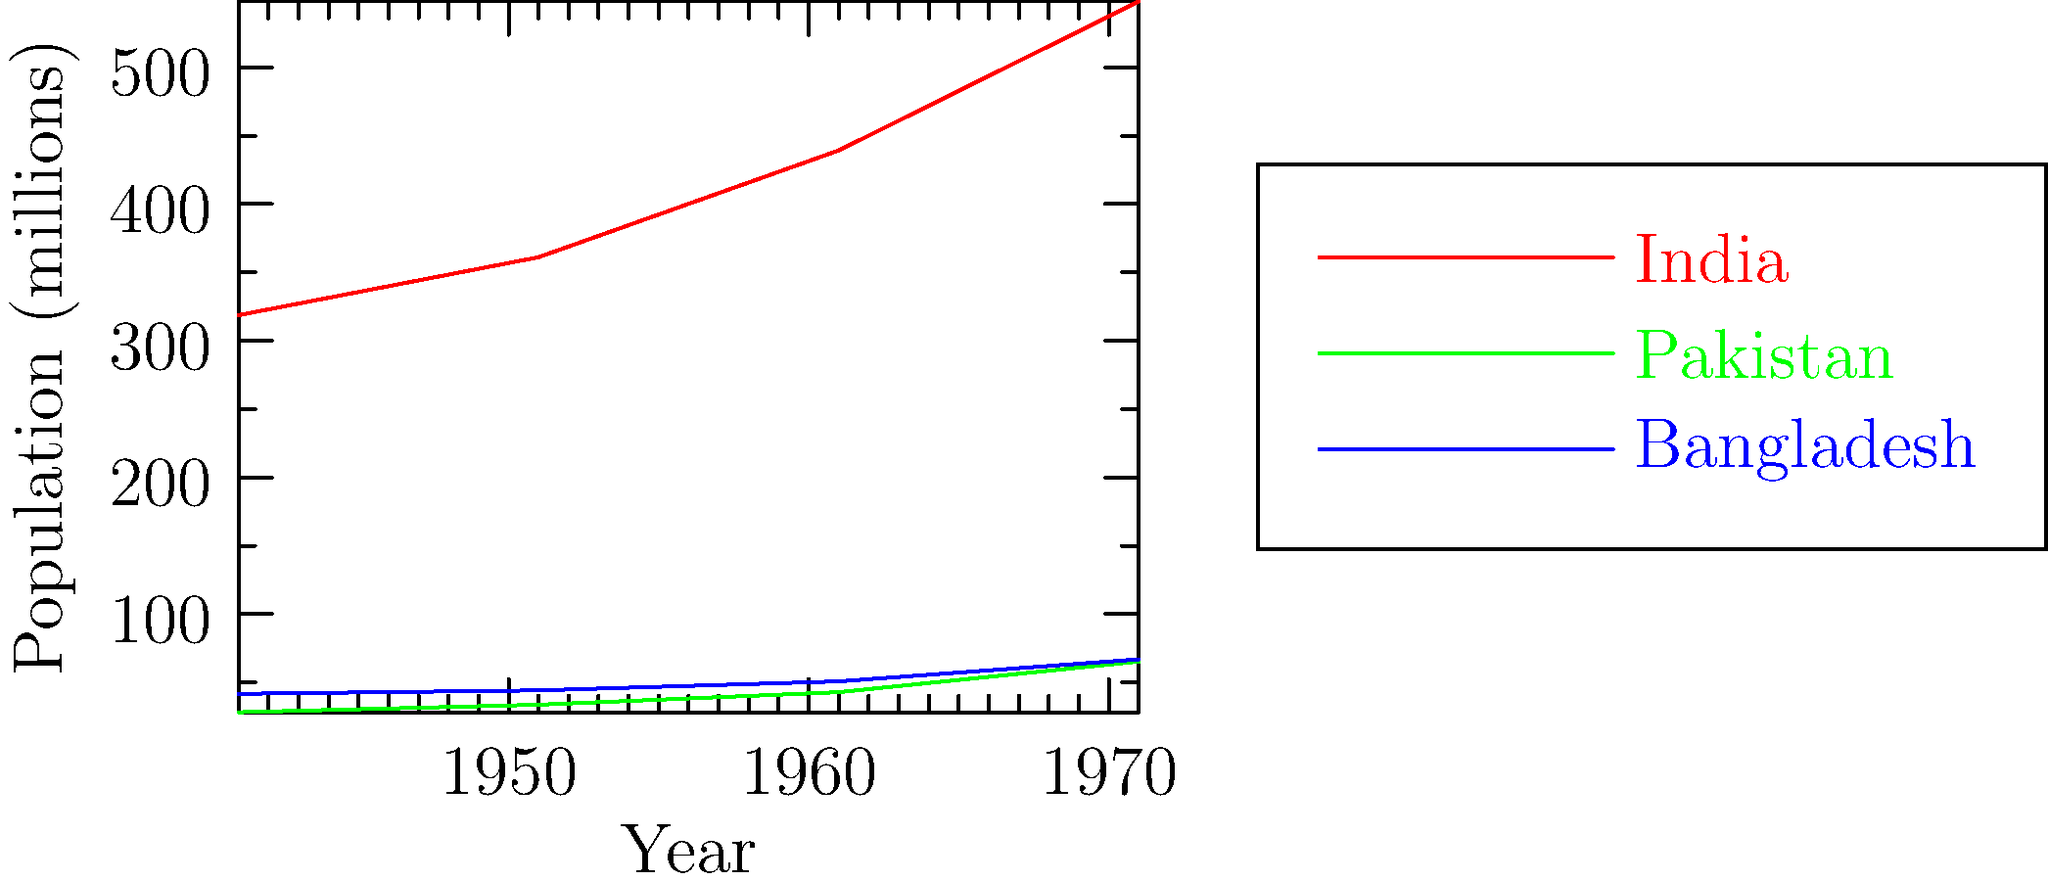Based on the line graph showing population changes in India, Pakistan, and Bangladesh from 1941 to 1971, which country experienced the highest percentage increase in population during this period? To determine which country had the highest percentage increase in population from 1941 to 1971, we need to calculate the percentage change for each country:

1. India:
   1941 population: 318.7 million
   1971 population: 548.2 million
   Percentage increase = (548.2 - 318.7) / 318.7 * 100 = 72.0%

2. Pakistan:
   1941 population: 28.2 million
   1971 population: 65.3 million
   Percentage increase = (65.3 - 28.2) / 28.2 * 100 = 131.6%

3. Bangladesh:
   1941 population: 41.7 million
   1971 population: 66.9 million
   Percentage increase = (66.9 - 41.7) / 41.7 * 100 = 60.4%

Comparing these percentages, we can see that Pakistan experienced the highest percentage increase in population during this period.

It's important to note that this data covers the period before and after the partition of India in 1947, as well as the creation of Bangladesh in 1971. The significant population increase in Pakistan can be attributed to factors such as migration during partition, high birth rates, and improved healthcare in the newly formed nation.
Answer: Pakistan 